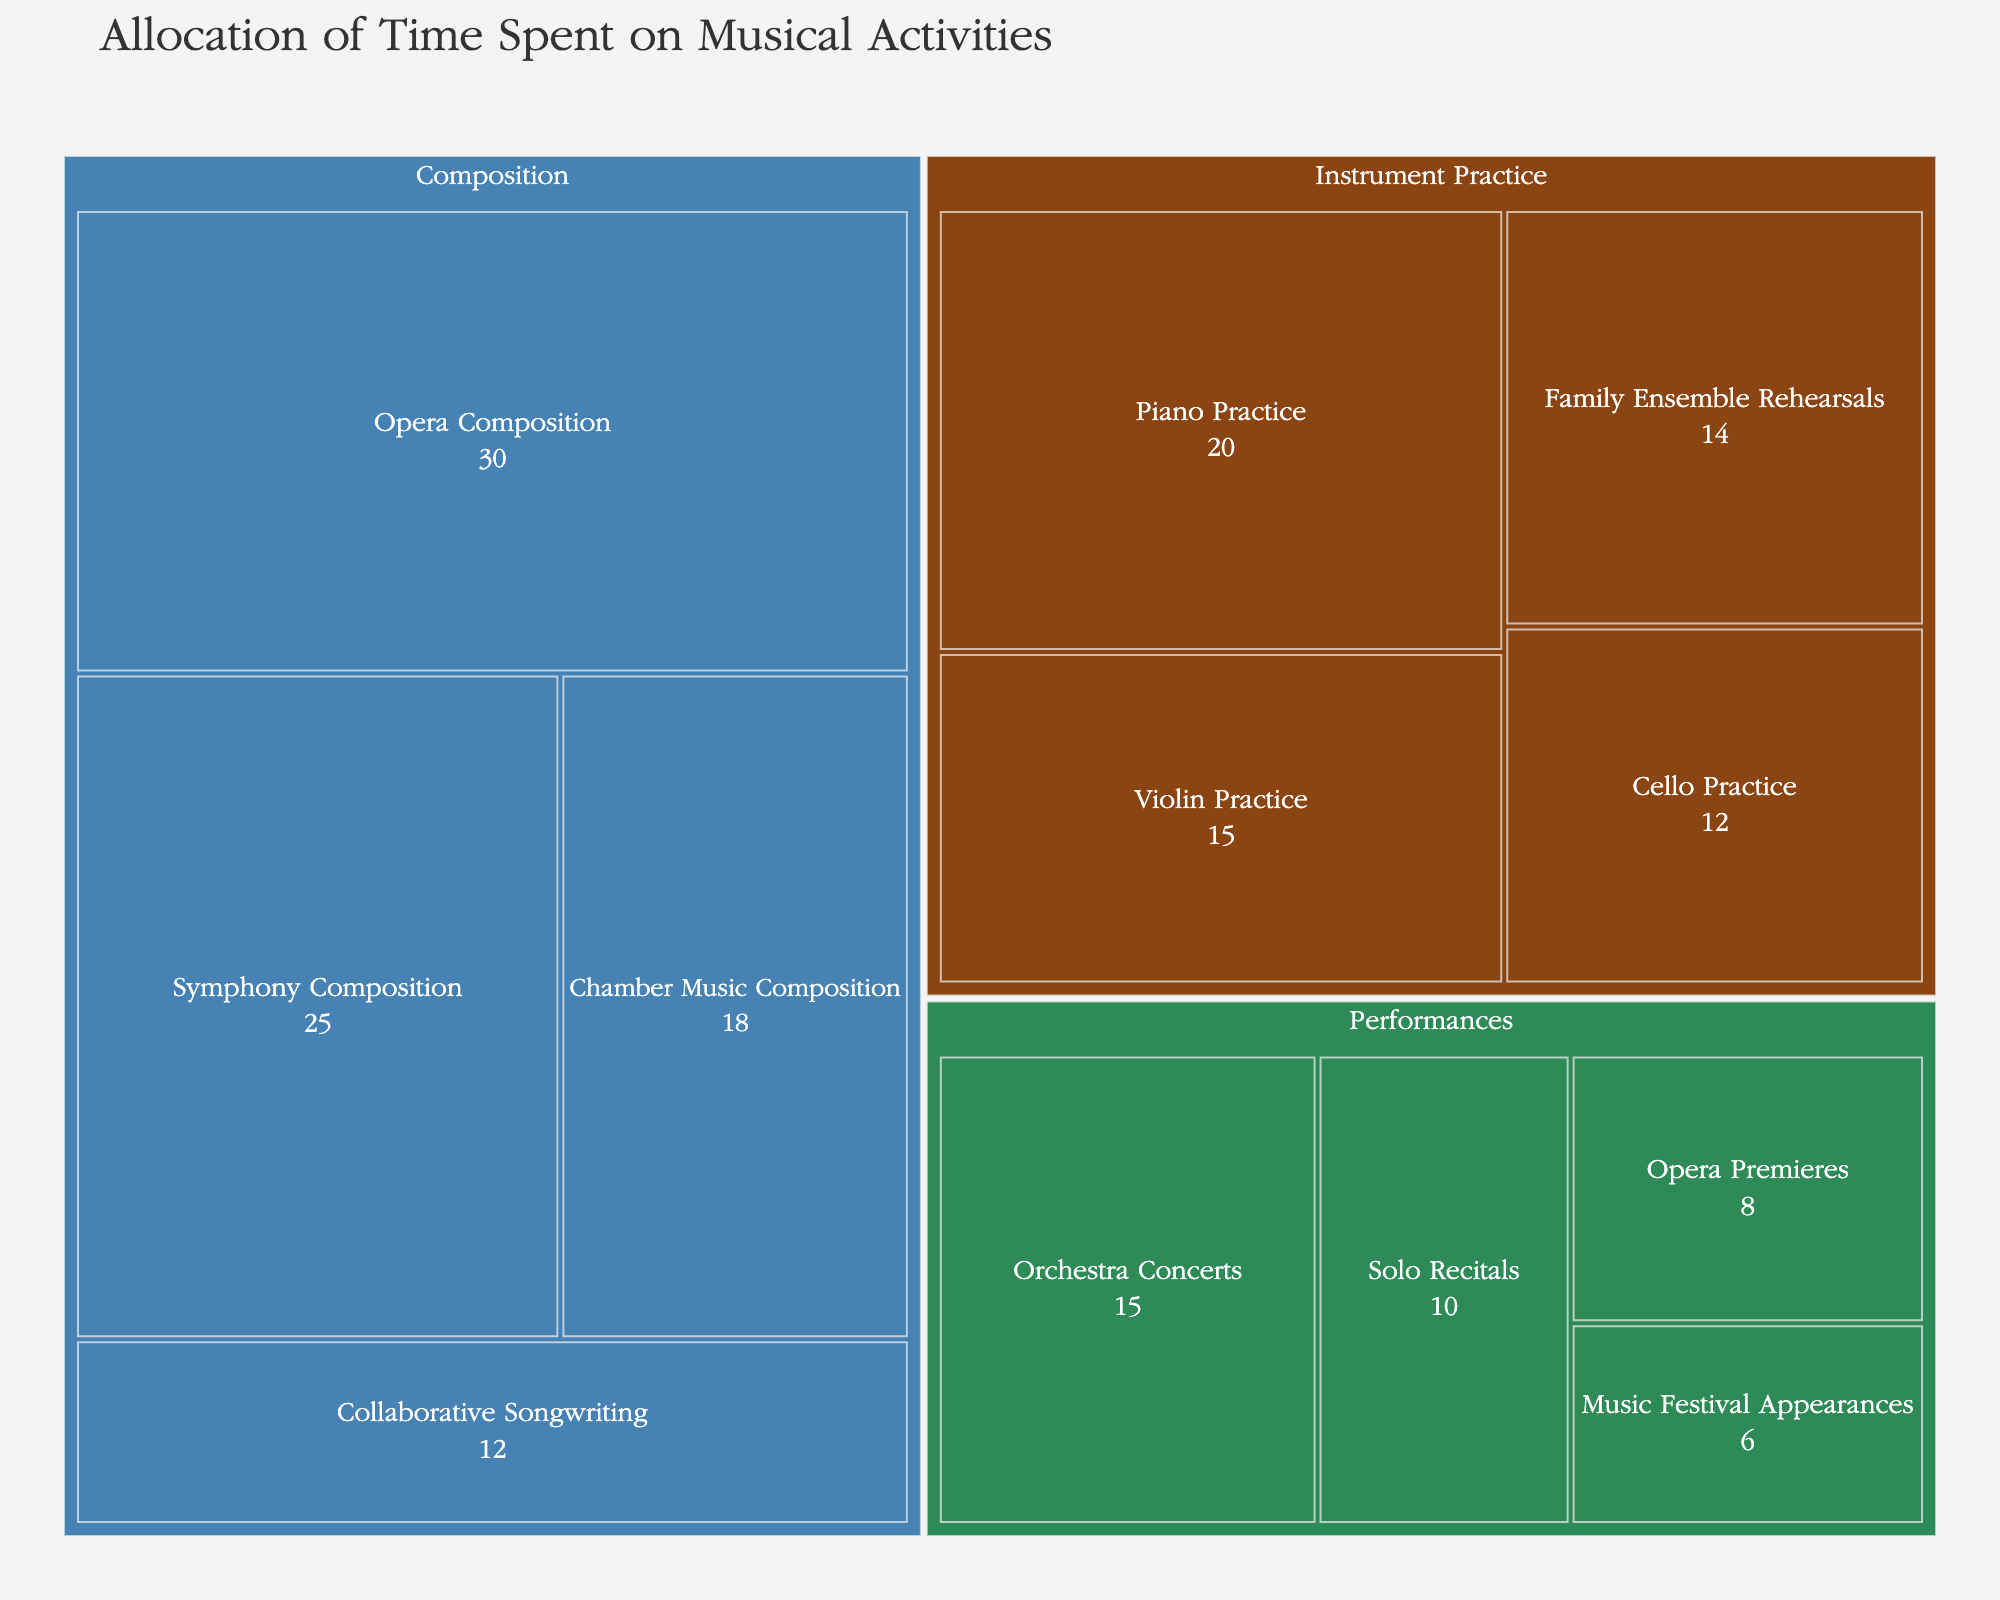What's the title of the plot? The title of the plot is located at the top and is prominently displayed in large text. It summarizes the main theme of the figure.
Answer: Allocation of Time Spent on Musical Activities How many hours are spent on Symphony Composition? Look for the segment labeled "Symphony Composition" under the Composition category, and read off the number of hours indicated within the segment.
Answer: 25 Which category has the most diverse set of activities? Check the number of unique activities listed under each primary category (Instrument Practice, Composition, Performances). Count how many distinct activities are present under each.
Answer: Composition What is the total number of hours spent on Performances? Locate all segments under the Performances category. Sum the hours from all these segments: Solo Recitals (10), Orchestra Concerts (15), Opera Premieres (8), Music Festival Appearances (6). 10 + 15 + 8 + 6 = 39.
Answer: 39 Which single musical activity is allocated the most hours? Identify which segment has the highest number of hours indicated within it. Compare all segments across categories to find the one with the highest value.
Answer: Opera Composition Is more time allocated to Violin Practice or Family Ensemble Rehearsals? Compare the number of hours indicated in the segments for Violin Practice and Family Ensemble Rehearsals.
Answer: Violin Practice What is the difference in hours between the least and most time-consuming activities? Determine the activity with the most hours (Opera Composition - 30) and the least (Music Festival Appearances - 6). Calculate the difference: 30 - 6 = 24.
Answer: 24 How many categories are shown in the treemap? Look at the primary divisions within the treemap, which are labeled with different colors and headings. Count these divisions.
Answer: 3 Which activity under Instrument Practice has the fewest hours? Find the segments under the Instrument Practice category, compare their hours, and identify the one with the smallest value.
Answer: Cello Practice 